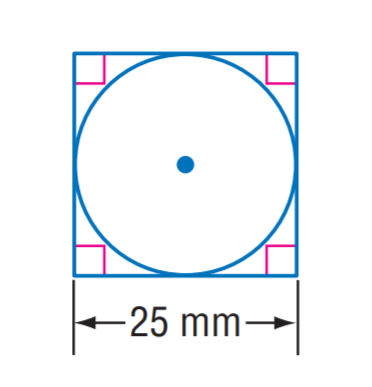Answer the mathemtical geometry problem and directly provide the correct option letter.
Question: The square is circumscribed to the circle. Find the exact circumference of the circle.
Choices: A: 12.5 \pi B: 25 \pi C: 30 \pi D: 50 \pi B 